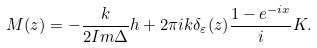<formula> <loc_0><loc_0><loc_500><loc_500>M ( z ) = - \frac { k } { 2 { I m } \Delta } h + 2 \pi i k \delta _ { \varepsilon } ( z ) \frac { 1 - e ^ { - i x } } { i } K .</formula> 